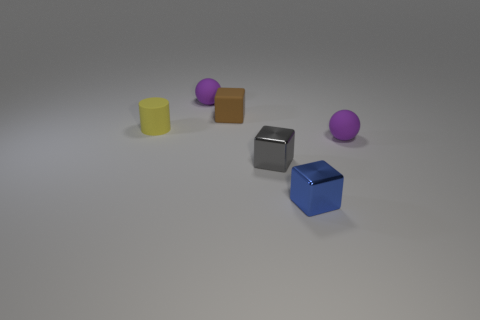What number of tiny rubber balls are on the right side of the small brown rubber thing and behind the small yellow rubber cylinder?
Provide a succinct answer. 0. What is the size of the cube that is made of the same material as the tiny gray thing?
Your answer should be compact. Small. How many other metal things are the same shape as the tiny gray thing?
Provide a succinct answer. 1. Are there more tiny rubber objects in front of the small yellow matte object than blue matte spheres?
Ensure brevity in your answer.  Yes. There is a thing that is both behind the small blue block and on the right side of the tiny gray metallic thing; what is its shape?
Offer a terse response. Sphere. Do the blue shiny cube and the matte cylinder have the same size?
Ensure brevity in your answer.  Yes. There is a tiny gray metal thing; how many tiny purple spheres are on the right side of it?
Your answer should be compact. 1. Is the number of small brown rubber objects in front of the cylinder the same as the number of small purple things on the right side of the small gray metallic block?
Your response must be concise. No. There is a shiny thing on the right side of the small gray metallic thing; does it have the same shape as the brown rubber thing?
Keep it short and to the point. Yes. What number of other objects are the same color as the small rubber cube?
Give a very brief answer. 0. 